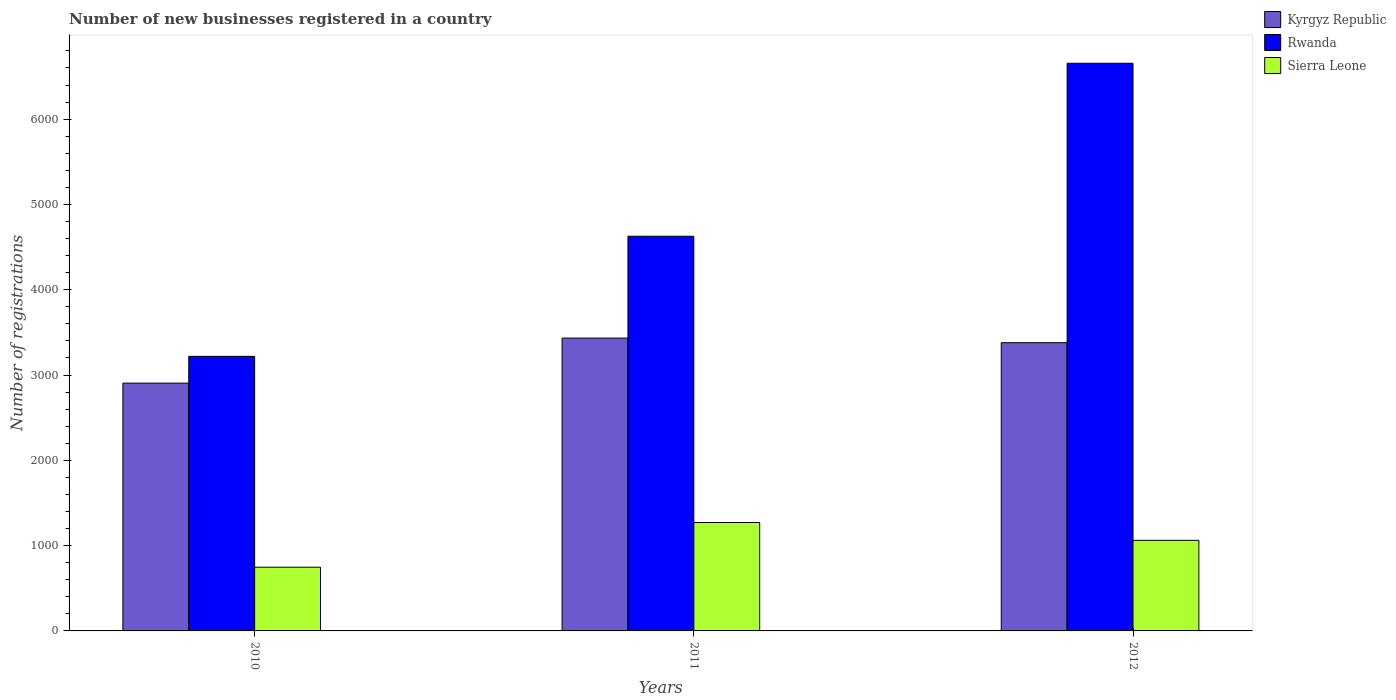How many different coloured bars are there?
Provide a succinct answer. 3. How many groups of bars are there?
Make the answer very short. 3. Are the number of bars per tick equal to the number of legend labels?
Keep it short and to the point. Yes. How many bars are there on the 2nd tick from the right?
Provide a succinct answer. 3. In how many cases, is the number of bars for a given year not equal to the number of legend labels?
Offer a terse response. 0. What is the number of new businesses registered in Kyrgyz Republic in 2010?
Provide a short and direct response. 2905. Across all years, what is the maximum number of new businesses registered in Sierra Leone?
Keep it short and to the point. 1271. Across all years, what is the minimum number of new businesses registered in Sierra Leone?
Ensure brevity in your answer.  747. In which year was the number of new businesses registered in Sierra Leone maximum?
Ensure brevity in your answer.  2011. What is the total number of new businesses registered in Rwanda in the graph?
Your response must be concise. 1.45e+04. What is the difference between the number of new businesses registered in Sierra Leone in 2010 and the number of new businesses registered in Rwanda in 2012?
Your answer should be compact. -5908. What is the average number of new businesses registered in Sierra Leone per year?
Provide a succinct answer. 1026.67. In the year 2012, what is the difference between the number of new businesses registered in Rwanda and number of new businesses registered in Sierra Leone?
Make the answer very short. 5593. What is the ratio of the number of new businesses registered in Sierra Leone in 2010 to that in 2012?
Your answer should be compact. 0.7. Is the difference between the number of new businesses registered in Rwanda in 2010 and 2012 greater than the difference between the number of new businesses registered in Sierra Leone in 2010 and 2012?
Give a very brief answer. No. What is the difference between the highest and the second highest number of new businesses registered in Kyrgyz Republic?
Ensure brevity in your answer.  54. What is the difference between the highest and the lowest number of new businesses registered in Kyrgyz Republic?
Provide a succinct answer. 528. In how many years, is the number of new businesses registered in Rwanda greater than the average number of new businesses registered in Rwanda taken over all years?
Keep it short and to the point. 1. What does the 1st bar from the left in 2012 represents?
Your response must be concise. Kyrgyz Republic. What does the 2nd bar from the right in 2010 represents?
Your answer should be compact. Rwanda. Is it the case that in every year, the sum of the number of new businesses registered in Rwanda and number of new businesses registered in Kyrgyz Republic is greater than the number of new businesses registered in Sierra Leone?
Give a very brief answer. Yes. How many years are there in the graph?
Provide a short and direct response. 3. What is the difference between two consecutive major ticks on the Y-axis?
Offer a very short reply. 1000. Are the values on the major ticks of Y-axis written in scientific E-notation?
Provide a succinct answer. No. Does the graph contain any zero values?
Keep it short and to the point. No. What is the title of the graph?
Offer a very short reply. Number of new businesses registered in a country. What is the label or title of the Y-axis?
Offer a terse response. Number of registrations. What is the Number of registrations of Kyrgyz Republic in 2010?
Ensure brevity in your answer.  2905. What is the Number of registrations in Rwanda in 2010?
Your answer should be compact. 3219. What is the Number of registrations in Sierra Leone in 2010?
Provide a succinct answer. 747. What is the Number of registrations in Kyrgyz Republic in 2011?
Give a very brief answer. 3433. What is the Number of registrations in Rwanda in 2011?
Your answer should be very brief. 4627. What is the Number of registrations in Sierra Leone in 2011?
Provide a succinct answer. 1271. What is the Number of registrations in Kyrgyz Republic in 2012?
Your answer should be very brief. 3379. What is the Number of registrations of Rwanda in 2012?
Offer a very short reply. 6655. What is the Number of registrations in Sierra Leone in 2012?
Offer a terse response. 1062. Across all years, what is the maximum Number of registrations in Kyrgyz Republic?
Your response must be concise. 3433. Across all years, what is the maximum Number of registrations of Rwanda?
Your answer should be very brief. 6655. Across all years, what is the maximum Number of registrations of Sierra Leone?
Offer a very short reply. 1271. Across all years, what is the minimum Number of registrations of Kyrgyz Republic?
Ensure brevity in your answer.  2905. Across all years, what is the minimum Number of registrations of Rwanda?
Provide a short and direct response. 3219. Across all years, what is the minimum Number of registrations of Sierra Leone?
Your answer should be very brief. 747. What is the total Number of registrations of Kyrgyz Republic in the graph?
Your answer should be very brief. 9717. What is the total Number of registrations in Rwanda in the graph?
Your answer should be very brief. 1.45e+04. What is the total Number of registrations in Sierra Leone in the graph?
Offer a very short reply. 3080. What is the difference between the Number of registrations in Kyrgyz Republic in 2010 and that in 2011?
Your answer should be very brief. -528. What is the difference between the Number of registrations of Rwanda in 2010 and that in 2011?
Keep it short and to the point. -1408. What is the difference between the Number of registrations of Sierra Leone in 2010 and that in 2011?
Provide a short and direct response. -524. What is the difference between the Number of registrations of Kyrgyz Republic in 2010 and that in 2012?
Provide a succinct answer. -474. What is the difference between the Number of registrations of Rwanda in 2010 and that in 2012?
Provide a succinct answer. -3436. What is the difference between the Number of registrations of Sierra Leone in 2010 and that in 2012?
Keep it short and to the point. -315. What is the difference between the Number of registrations in Kyrgyz Republic in 2011 and that in 2012?
Make the answer very short. 54. What is the difference between the Number of registrations of Rwanda in 2011 and that in 2012?
Keep it short and to the point. -2028. What is the difference between the Number of registrations in Sierra Leone in 2011 and that in 2012?
Your response must be concise. 209. What is the difference between the Number of registrations of Kyrgyz Republic in 2010 and the Number of registrations of Rwanda in 2011?
Provide a succinct answer. -1722. What is the difference between the Number of registrations of Kyrgyz Republic in 2010 and the Number of registrations of Sierra Leone in 2011?
Offer a very short reply. 1634. What is the difference between the Number of registrations of Rwanda in 2010 and the Number of registrations of Sierra Leone in 2011?
Your answer should be very brief. 1948. What is the difference between the Number of registrations in Kyrgyz Republic in 2010 and the Number of registrations in Rwanda in 2012?
Provide a short and direct response. -3750. What is the difference between the Number of registrations in Kyrgyz Republic in 2010 and the Number of registrations in Sierra Leone in 2012?
Your answer should be very brief. 1843. What is the difference between the Number of registrations in Rwanda in 2010 and the Number of registrations in Sierra Leone in 2012?
Your response must be concise. 2157. What is the difference between the Number of registrations in Kyrgyz Republic in 2011 and the Number of registrations in Rwanda in 2012?
Your response must be concise. -3222. What is the difference between the Number of registrations of Kyrgyz Republic in 2011 and the Number of registrations of Sierra Leone in 2012?
Keep it short and to the point. 2371. What is the difference between the Number of registrations in Rwanda in 2011 and the Number of registrations in Sierra Leone in 2012?
Make the answer very short. 3565. What is the average Number of registrations of Kyrgyz Republic per year?
Offer a very short reply. 3239. What is the average Number of registrations of Rwanda per year?
Your answer should be compact. 4833.67. What is the average Number of registrations of Sierra Leone per year?
Make the answer very short. 1026.67. In the year 2010, what is the difference between the Number of registrations of Kyrgyz Republic and Number of registrations of Rwanda?
Your answer should be very brief. -314. In the year 2010, what is the difference between the Number of registrations in Kyrgyz Republic and Number of registrations in Sierra Leone?
Ensure brevity in your answer.  2158. In the year 2010, what is the difference between the Number of registrations of Rwanda and Number of registrations of Sierra Leone?
Offer a very short reply. 2472. In the year 2011, what is the difference between the Number of registrations in Kyrgyz Republic and Number of registrations in Rwanda?
Offer a very short reply. -1194. In the year 2011, what is the difference between the Number of registrations in Kyrgyz Republic and Number of registrations in Sierra Leone?
Ensure brevity in your answer.  2162. In the year 2011, what is the difference between the Number of registrations in Rwanda and Number of registrations in Sierra Leone?
Offer a terse response. 3356. In the year 2012, what is the difference between the Number of registrations of Kyrgyz Republic and Number of registrations of Rwanda?
Provide a short and direct response. -3276. In the year 2012, what is the difference between the Number of registrations of Kyrgyz Republic and Number of registrations of Sierra Leone?
Your answer should be compact. 2317. In the year 2012, what is the difference between the Number of registrations in Rwanda and Number of registrations in Sierra Leone?
Your answer should be very brief. 5593. What is the ratio of the Number of registrations of Kyrgyz Republic in 2010 to that in 2011?
Give a very brief answer. 0.85. What is the ratio of the Number of registrations in Rwanda in 2010 to that in 2011?
Keep it short and to the point. 0.7. What is the ratio of the Number of registrations in Sierra Leone in 2010 to that in 2011?
Ensure brevity in your answer.  0.59. What is the ratio of the Number of registrations of Kyrgyz Republic in 2010 to that in 2012?
Keep it short and to the point. 0.86. What is the ratio of the Number of registrations of Rwanda in 2010 to that in 2012?
Your response must be concise. 0.48. What is the ratio of the Number of registrations of Sierra Leone in 2010 to that in 2012?
Offer a very short reply. 0.7. What is the ratio of the Number of registrations of Kyrgyz Republic in 2011 to that in 2012?
Keep it short and to the point. 1.02. What is the ratio of the Number of registrations of Rwanda in 2011 to that in 2012?
Give a very brief answer. 0.7. What is the ratio of the Number of registrations of Sierra Leone in 2011 to that in 2012?
Provide a succinct answer. 1.2. What is the difference between the highest and the second highest Number of registrations in Rwanda?
Give a very brief answer. 2028. What is the difference between the highest and the second highest Number of registrations in Sierra Leone?
Make the answer very short. 209. What is the difference between the highest and the lowest Number of registrations in Kyrgyz Republic?
Provide a succinct answer. 528. What is the difference between the highest and the lowest Number of registrations in Rwanda?
Your response must be concise. 3436. What is the difference between the highest and the lowest Number of registrations in Sierra Leone?
Provide a succinct answer. 524. 